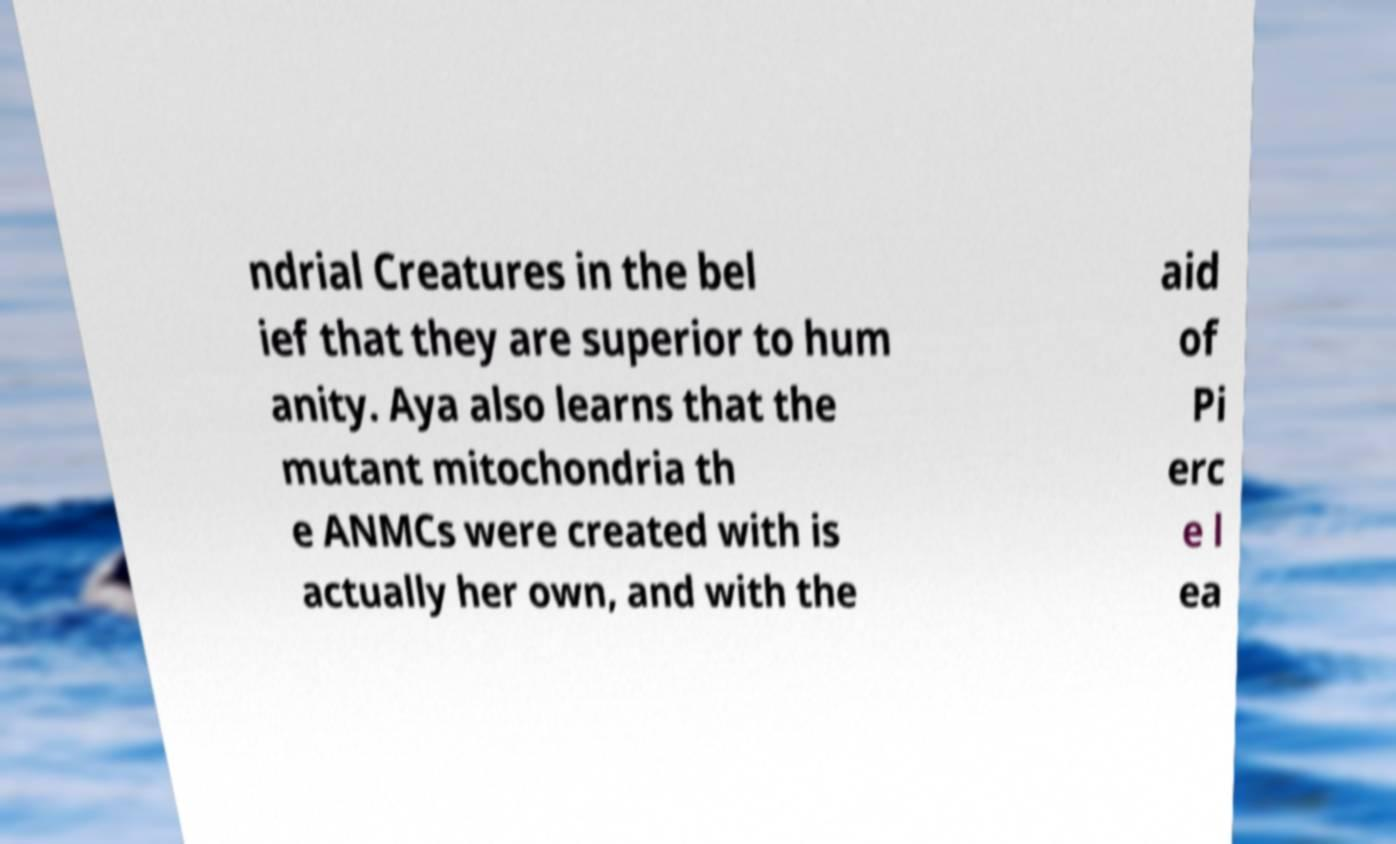There's text embedded in this image that I need extracted. Can you transcribe it verbatim? ndrial Creatures in the bel ief that they are superior to hum anity. Aya also learns that the mutant mitochondria th e ANMCs were created with is actually her own, and with the aid of Pi erc e l ea 